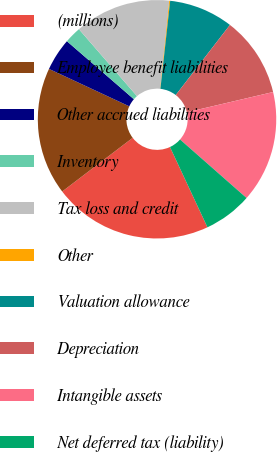Convert chart. <chart><loc_0><loc_0><loc_500><loc_500><pie_chart><fcel>(millions)<fcel>Employee benefit liabilities<fcel>Other accrued liabilities<fcel>Inventory<fcel>Tax loss and credit<fcel>Other<fcel>Valuation allowance<fcel>Depreciation<fcel>Intangible assets<fcel>Net deferred tax (liability)<nl><fcel>21.59%<fcel>17.3%<fcel>4.42%<fcel>2.27%<fcel>13.0%<fcel>0.13%<fcel>8.71%<fcel>10.86%<fcel>15.15%<fcel>6.57%<nl></chart> 